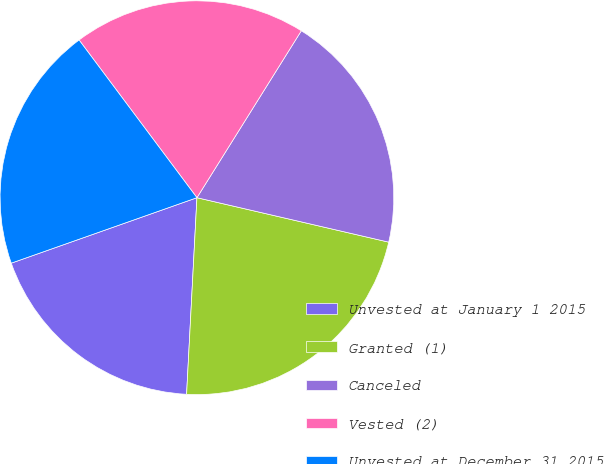Convert chart. <chart><loc_0><loc_0><loc_500><loc_500><pie_chart><fcel>Unvested at January 1 2015<fcel>Granted (1)<fcel>Canceled<fcel>Vested (2)<fcel>Unvested at December 31 2015<nl><fcel>18.77%<fcel>22.21%<fcel>19.73%<fcel>19.11%<fcel>20.18%<nl></chart> 